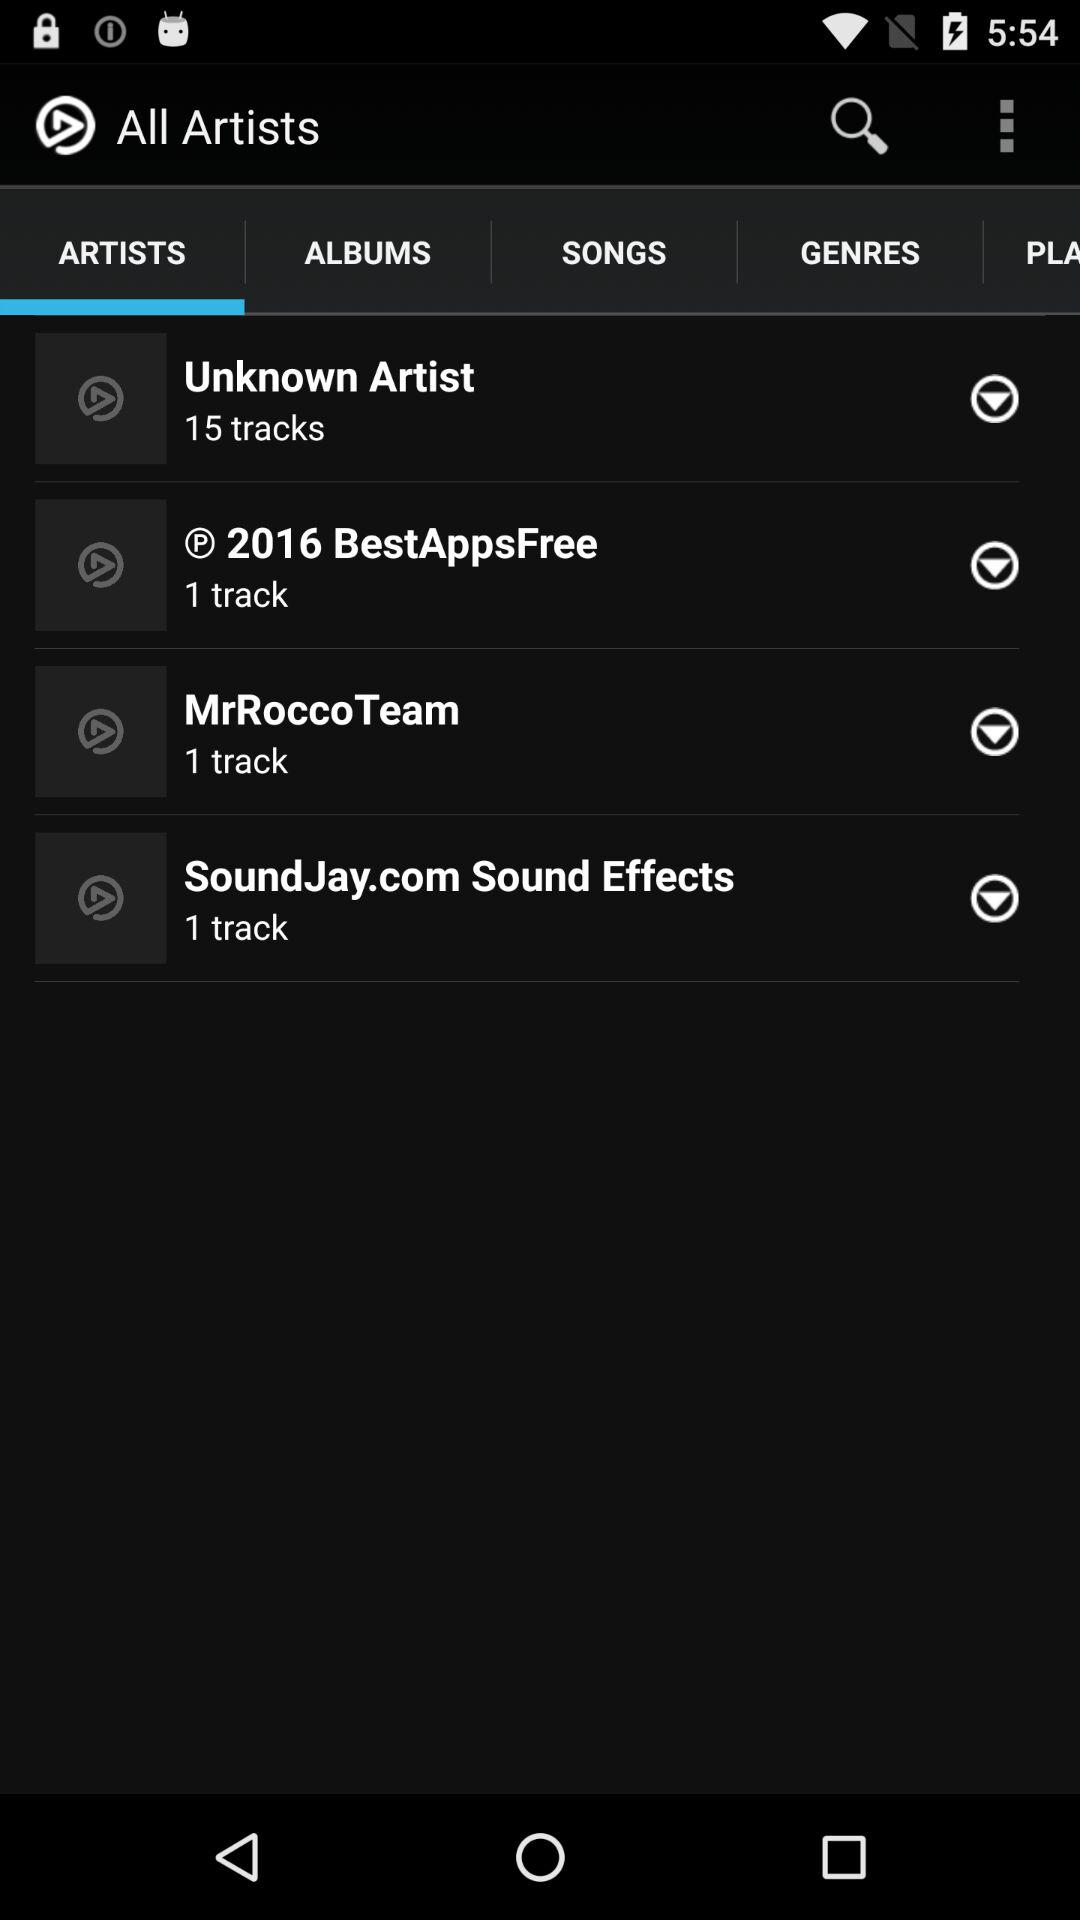Which tab is selected? The selected tab is "ARTISTS". 